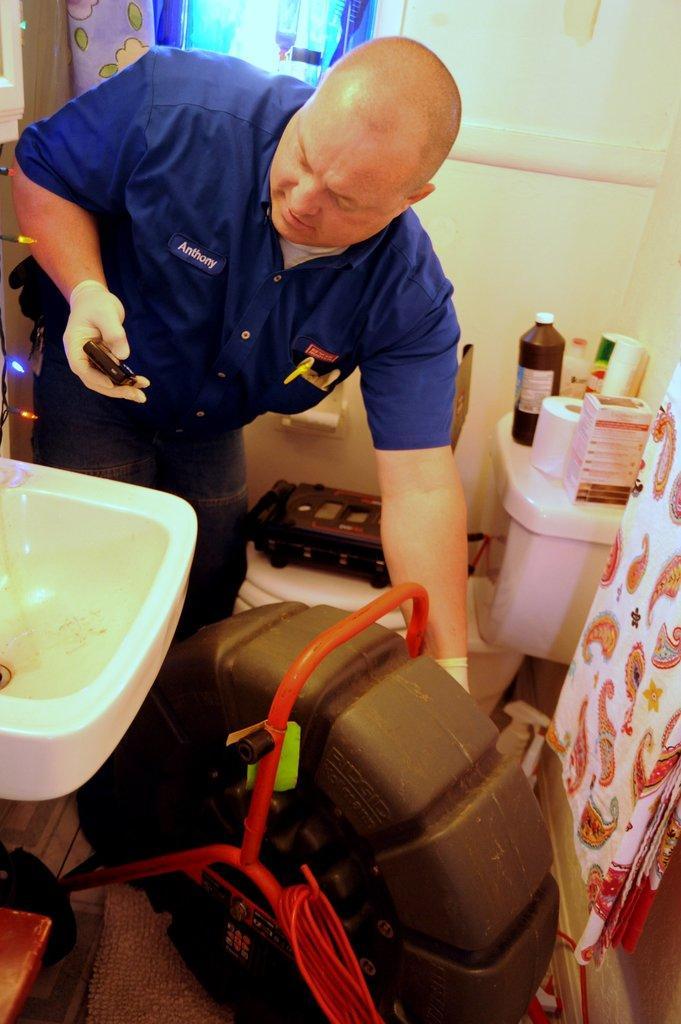Can you describe this image briefly? In this image a person wearing a blue shirt is holding a mobile in his hand. Before him there is a sink. There is an object on the floor. Right side there is a cloth. Beside there is a toilet seat having flush tank. On top of it there is a bottle, paper roll and few objects are on it. On toilet seat there is a device on it. Behind the person there is a curtain. 